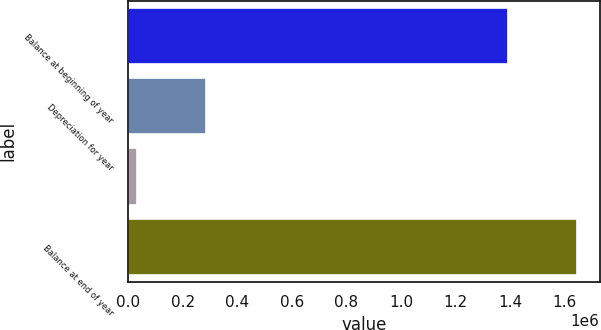Convert chart. <chart><loc_0><loc_0><loc_500><loc_500><bar_chart><fcel>Balance at beginning of year<fcel>Depreciation for year<fcel>Unnamed: 2<fcel>Balance at end of year<nl><fcel>1.39332e+06<fcel>286776<fcel>33859<fcel>1.64624e+06<nl></chart> 